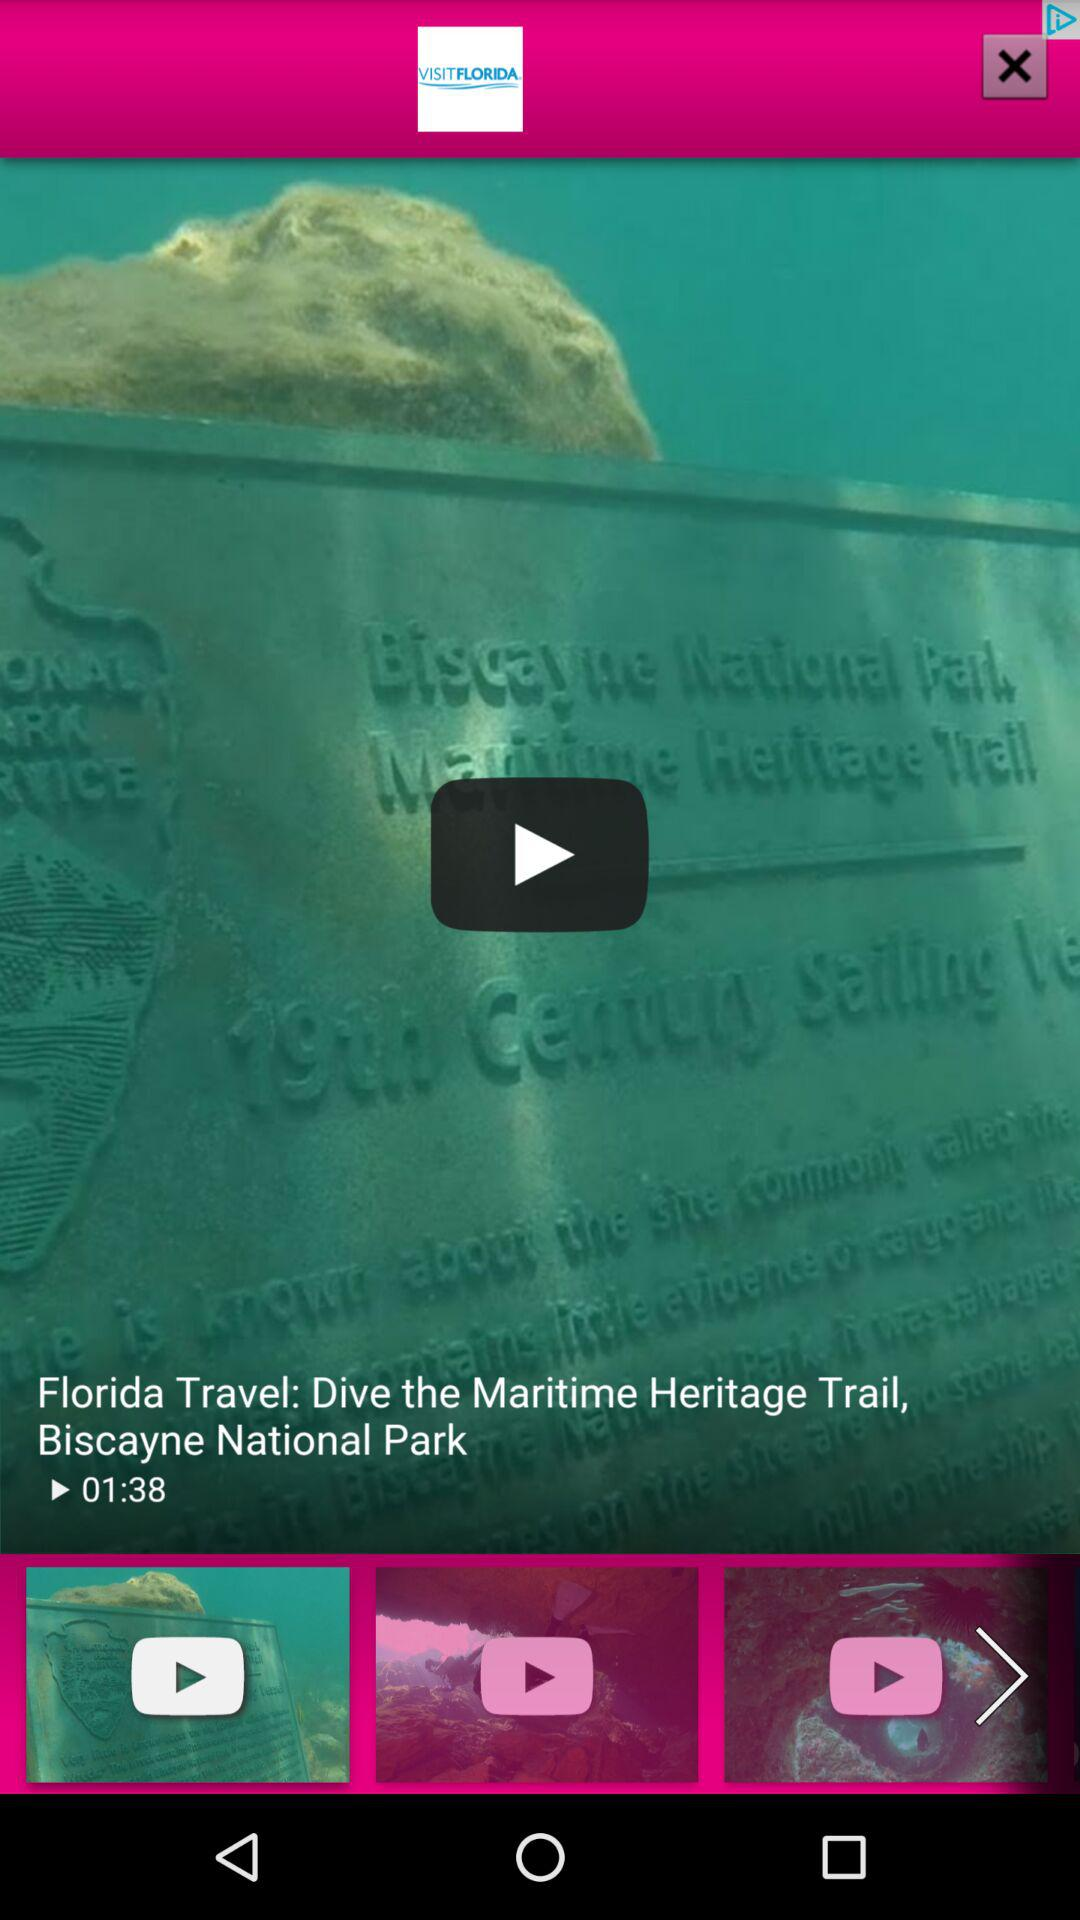What's the name of the video? The name of the video is "Florida Travel: Dive the Maritime Heritage Trail, Biscayne National Park". 